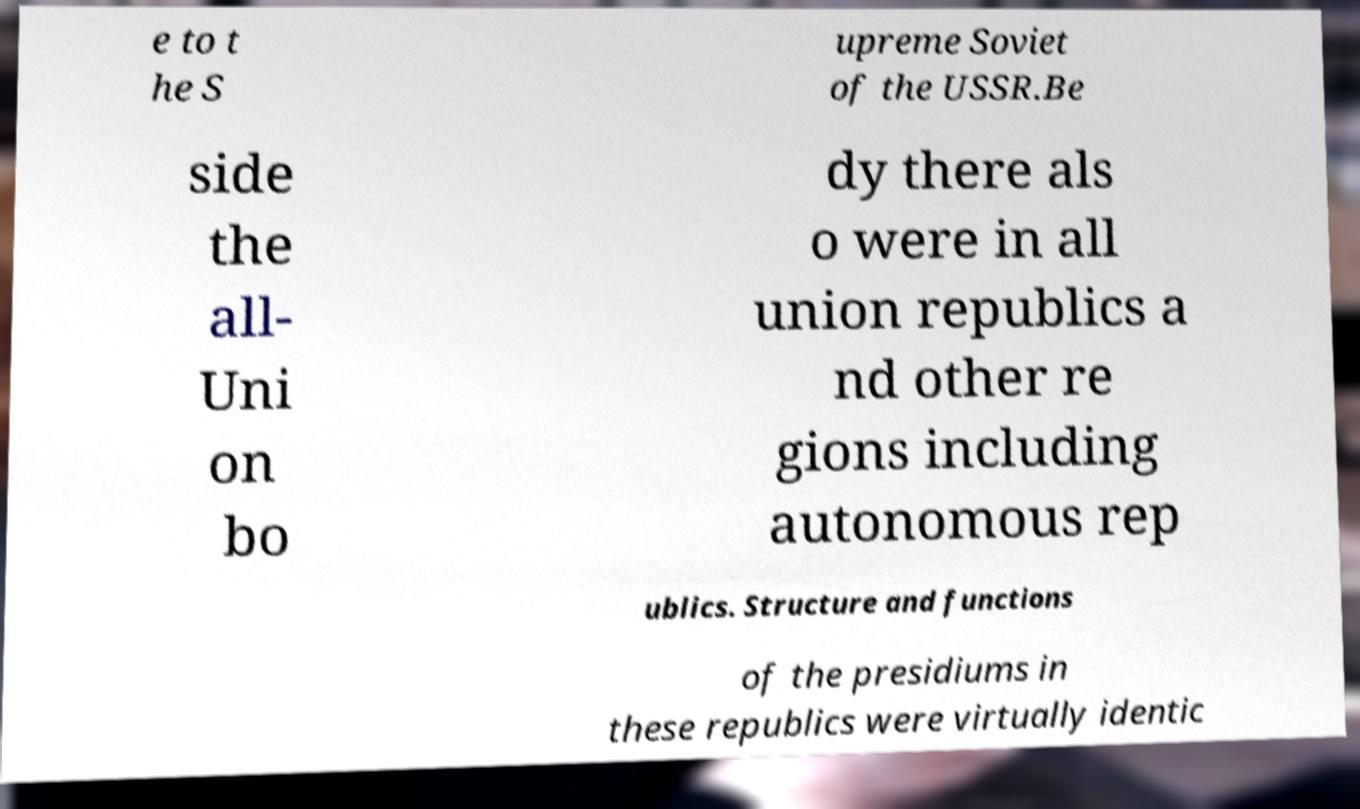For documentation purposes, I need the text within this image transcribed. Could you provide that? e to t he S upreme Soviet of the USSR.Be side the all- Uni on bo dy there als o were in all union republics a nd other re gions including autonomous rep ublics. Structure and functions of the presidiums in these republics were virtually identic 